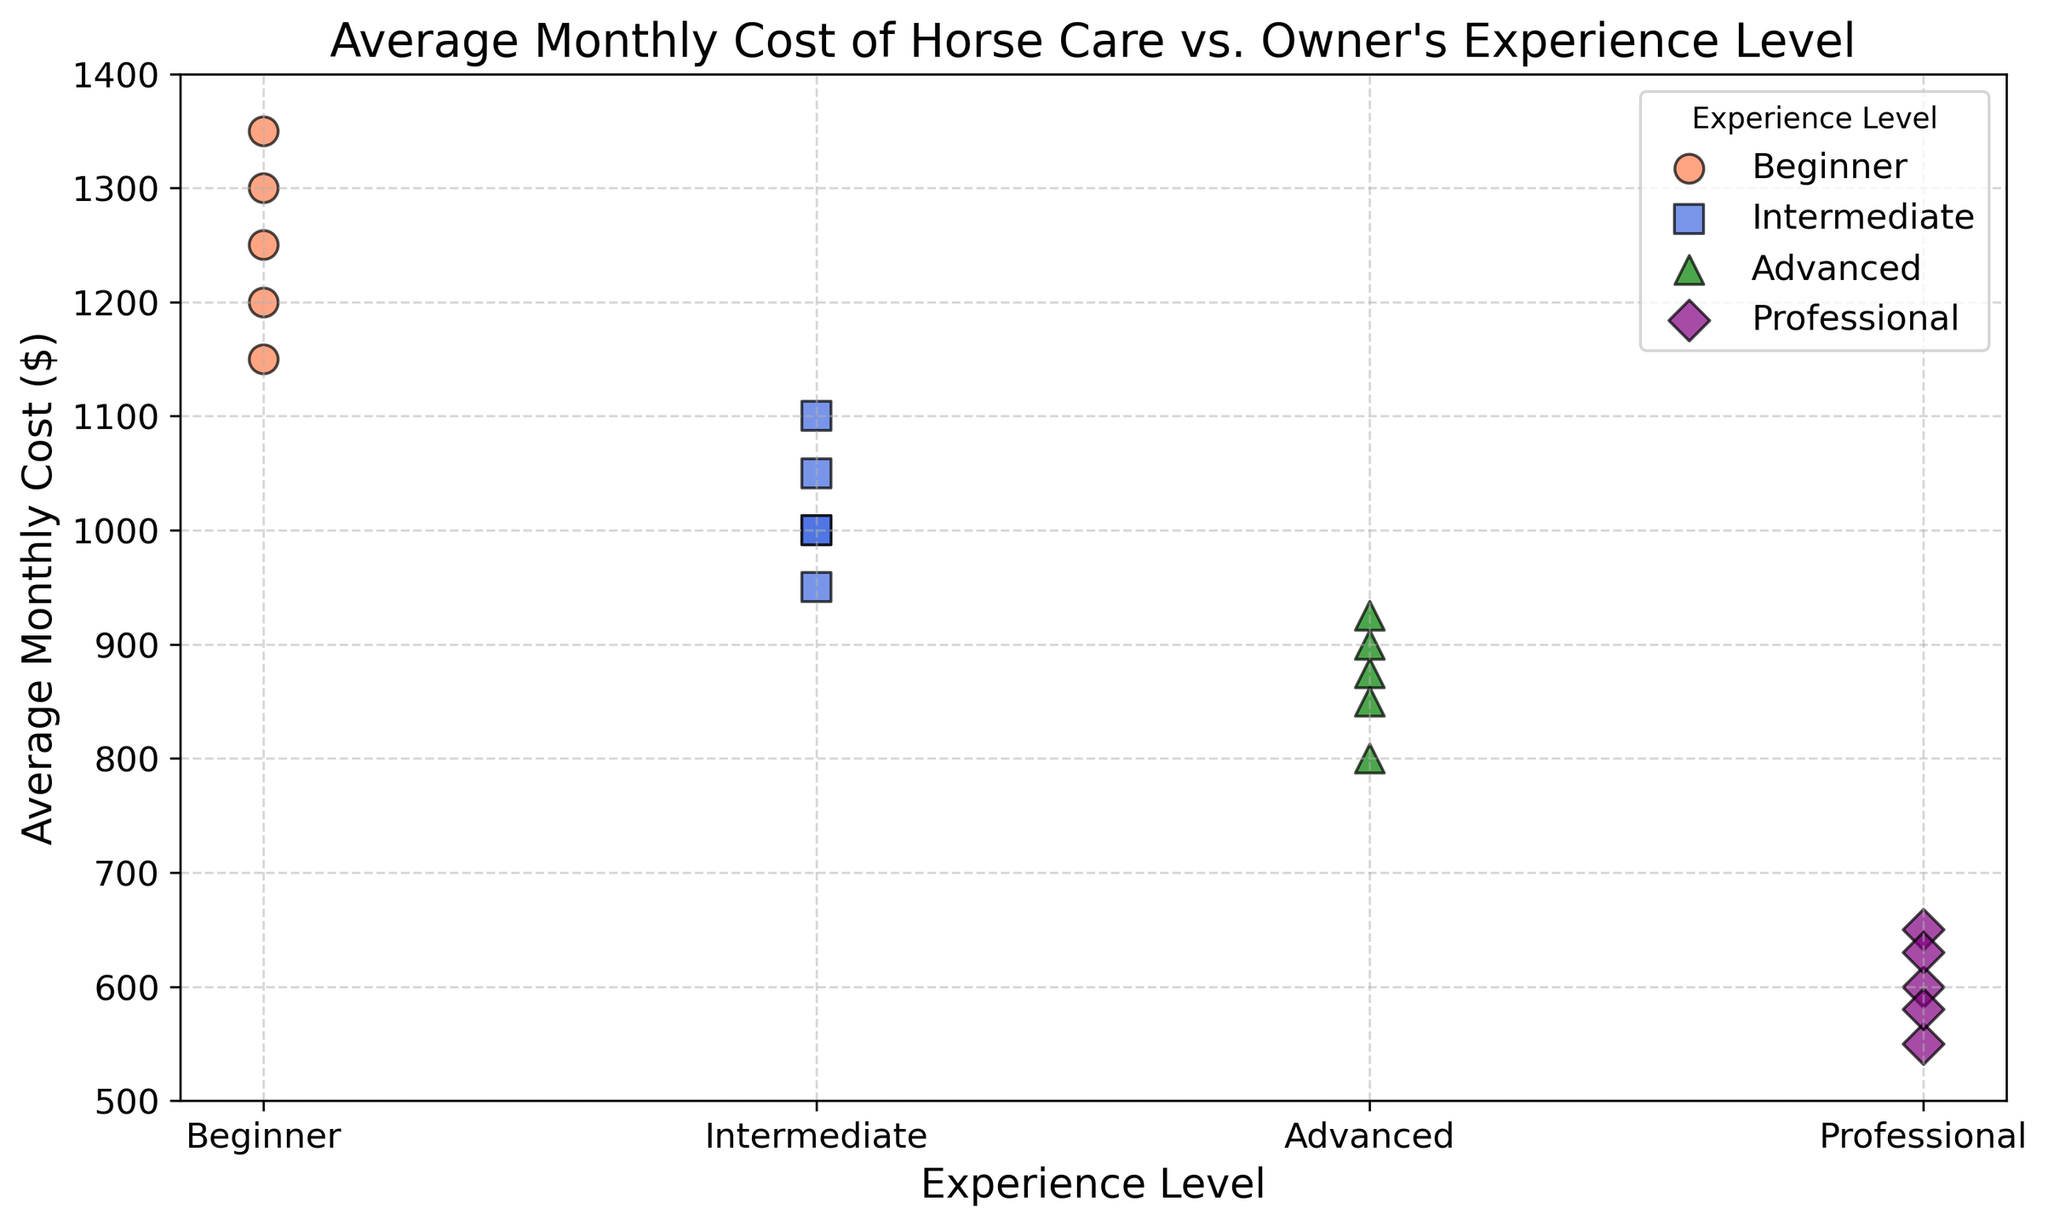What's the average monthly cost for Intermediate owners? To find the average monthly cost for Intermediate owners, sum up all the costs for Intermediate owners and then divide by the number of data points. The costs are 1000, 950, 1050, and 1100. The total is 1000 + 950 + 1050 + 1100 = 4100. There are 4 data points, so the average is 4100 / 4.
Answer: 1025 Which experience level has the lowest average monthly cost? Look at the data points for each experience level and calculate the average for each group. Professionals have costs at 600, 550, 650, 580, and 630. The average is (600 + 550 + 650 + 580 + 630) / 5, which is 3020 / 5. Advanced, Intermediate, and Beginner have higher averages.
Answer: Professional Which group has the highest individual monthly cost? Examine the scatter plot to find the highest data point. Beginners have the highest individual cost, which is above 1300 (1350).
Answer: Beginners Do Advanced owners tend to spend more or less than Intermediate owners? Compare the range of costs for Advanced and Intermediate owners. Advanced owners have costs between 800 and 925, while Intermediate owners have costs between 950 and 1100.
Answer: Less What is the range of monthly costs for Professional owners? Look at the lowest and highest individual costs in the Professional group. The costs range from 550 to 650.
Answer: 100 Which group has the most spread in monthly costs? Find the range for each experience level. Beginners have a spread from 1150 to 1350, Intermediate from 950 to 1100, Advanced from 800 to 925, and Professionals from 550 to 650. Beginners have the largest spread (200).
Answer: Beginners Is there overlap in monthly costs between Advanced and Professional owners? Compare the data points for Advanced and Professional groups. Advanced owners have costs that overlap with the higher end of Professional costs (900, 850, 800 vs. 600-650 range).
Answer: Yes 